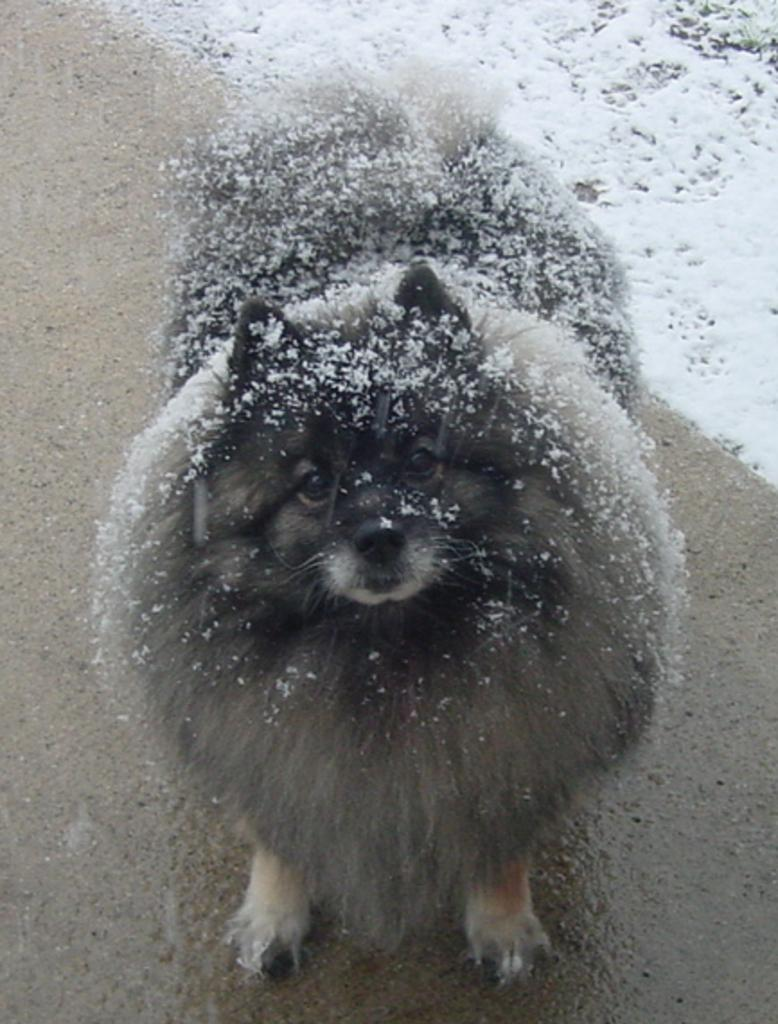What type of animal is in the picture? There is a dog in the picture. Where is the dog standing? The dog is standing on a path. What is the condition of the path? The path is covered in snow. What is the physical characteristic of the dog? The dog has fur. Is there any snow on the dog? Yes, there is snow on the dog. What type of vegetable is the dog holding in the image? There is no vegetable present in the image, and the dog is not holding anything. 